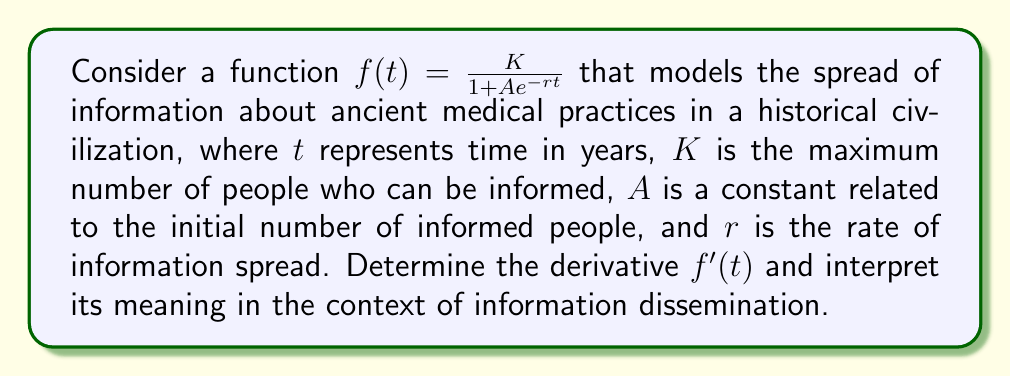Help me with this question. To find the derivative of $f(t)$, we'll use the quotient rule:

$$f'(t) = \frac{(1 + Ae^{-rt}) \cdot \frac{d}{dt}(K) - K \cdot \frac{d}{dt}(1 + Ae^{-rt})}{(1 + Ae^{-rt})^2}$$

1) First, $\frac{d}{dt}(K) = 0$ since $K$ is a constant.

2) For the denominator: $\frac{d}{dt}(1 + Ae^{-rt}) = A \cdot \frac{d}{dt}(e^{-rt}) = A \cdot (-r)e^{-rt} = -Are^{-rt}$

3) Substituting these into the quotient rule:

   $$f'(t) = \frac{0 - K(-Are^{-rt})}{(1 + Ae^{-rt})^2} = \frac{KAre^{-rt}}{(1 + Ae^{-rt})^2}$$

4) We can factor out $K$ and $r$:

   $$f'(t) = Kr \cdot \frac{Ae^{-rt}}{(1 + Ae^{-rt})^2}$$

5) Recall that $f(t) = \frac{K}{1 + Ae^{-rt}}$. We can rewrite this as:

   $$f(t) = K \cdot \frac{1}{1 + Ae^{-rt}}$$

6) Squaring this:

   $$[f(t)]^2 = K^2 \cdot \frac{1}{(1 + Ae^{-rt})^2}$$

7) Dividing $f(t)$ by $K$:

   $$\frac{f(t)}{K} = \frac{1}{1 + Ae^{-rt}}$$

8) Subtracting this from 1:

   $$1 - \frac{f(t)}{K} = 1 - \frac{1}{1 + Ae^{-rt}} = \frac{Ae^{-rt}}{1 + Ae^{-rt}}$$

9) Therefore, we can express $f'(t)$ as:

   $$f'(t) = Kr \cdot \frac{f(t)}{K} \cdot (1 - \frac{f(t)}{K}) = rf(t)(1 - \frac{f(t)}{K})$$

Interpretation: The derivative $f'(t)$ represents the rate of change of information spread at time $t$. It is proportional to the current number of informed people $f(t)$ and the number of uninformed people $(K - f(t))$, with $r$ as the proportionality constant. This reflects that the spread of information depends on interactions between informed and uninformed individuals.
Answer: $$f'(t) = rf(t)(1 - \frac{f(t)}{K})$$ 